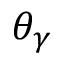<formula> <loc_0><loc_0><loc_500><loc_500>\theta _ { \gamma }</formula> 